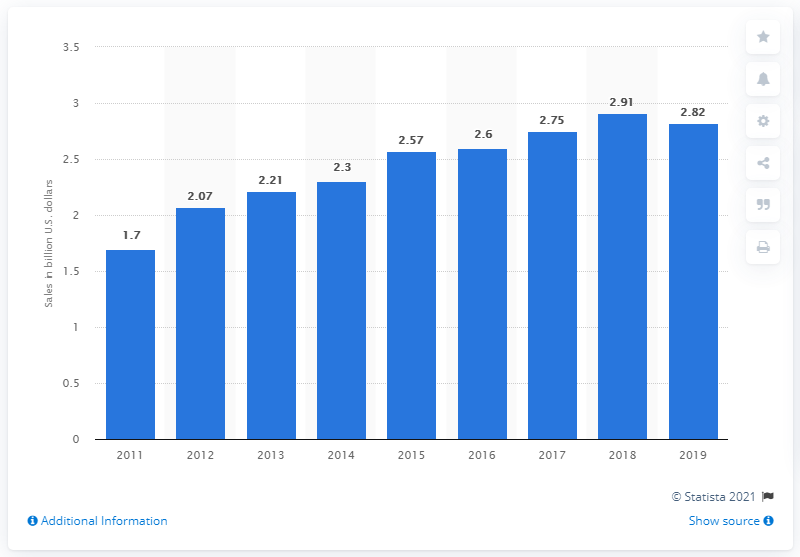Specify some key components in this picture. In 2019, Gildan's revenue was 2.82 billion. In 2011, Gildan generated approximately 1.7 billion dollars in revenue in the United States. 